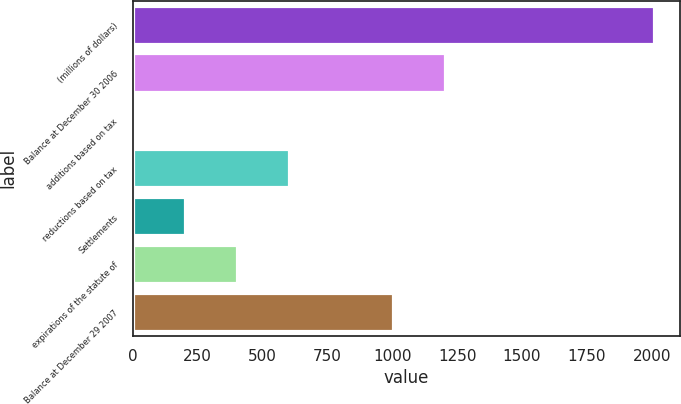Convert chart to OTSL. <chart><loc_0><loc_0><loc_500><loc_500><bar_chart><fcel>(millions of dollars)<fcel>Balance at December 30 2006<fcel>additions based on tax<fcel>reductions based on tax<fcel>Settlements<fcel>expirations of the statute of<fcel>Balance at December 29 2007<nl><fcel>2007<fcel>1204.92<fcel>1.8<fcel>603.36<fcel>202.32<fcel>402.84<fcel>1004.4<nl></chart> 